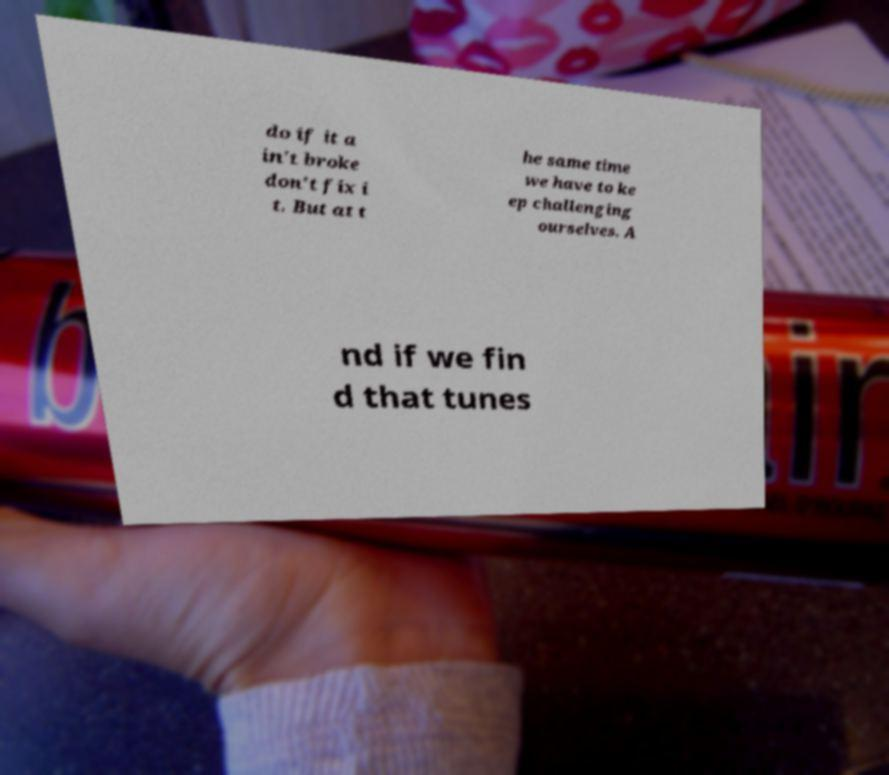For documentation purposes, I need the text within this image transcribed. Could you provide that? do if it a in't broke don't fix i t. But at t he same time we have to ke ep challenging ourselves. A nd if we fin d that tunes 